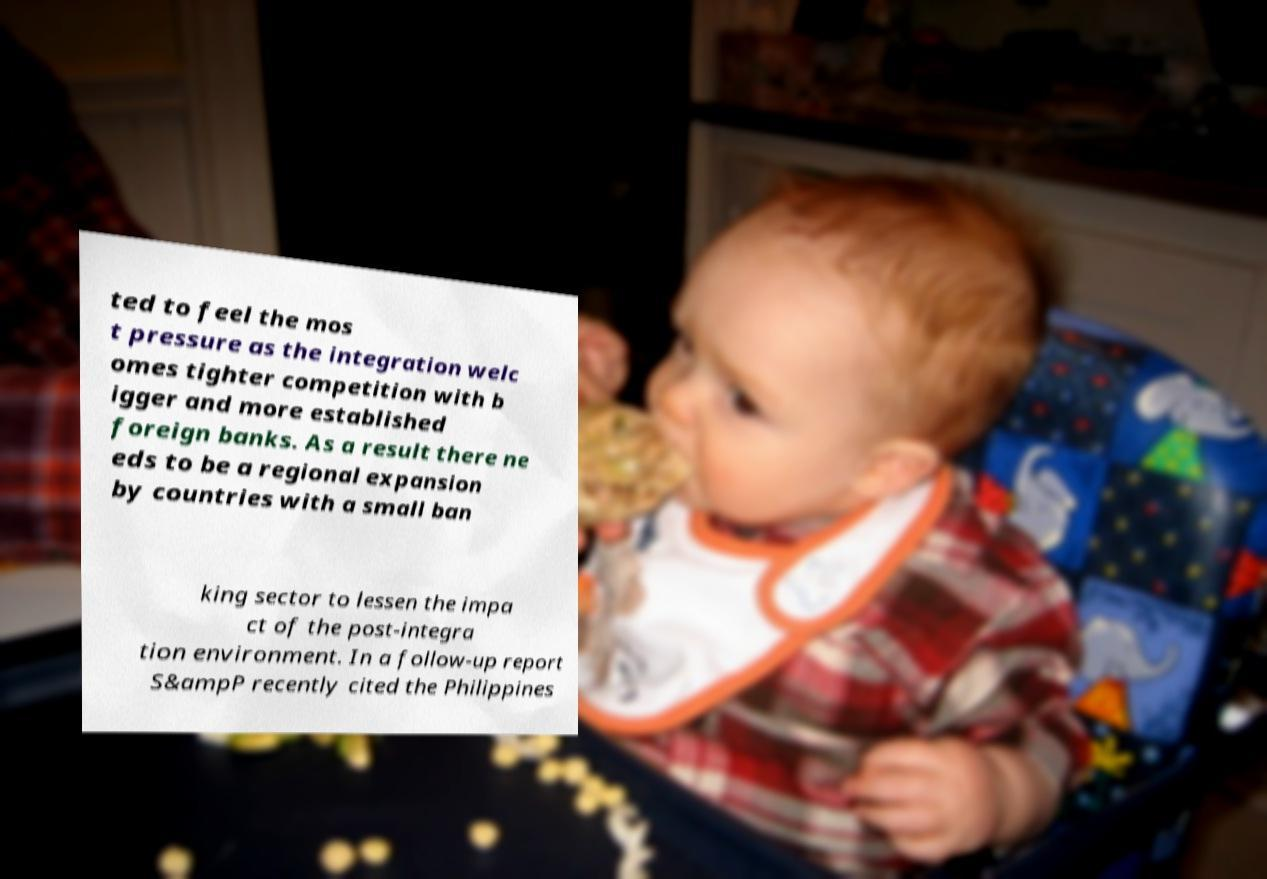I need the written content from this picture converted into text. Can you do that? ted to feel the mos t pressure as the integration welc omes tighter competition with b igger and more established foreign banks. As a result there ne eds to be a regional expansion by countries with a small ban king sector to lessen the impa ct of the post-integra tion environment. In a follow-up report S&ampP recently cited the Philippines 